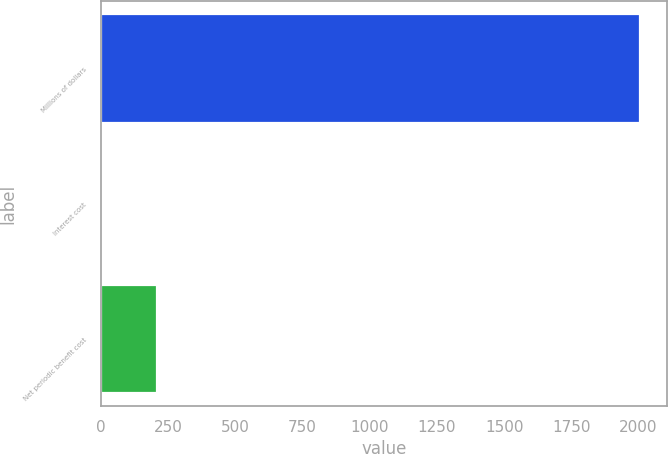Convert chart. <chart><loc_0><loc_0><loc_500><loc_500><bar_chart><fcel>Millions of dollars<fcel>Interest cost<fcel>Net periodic benefit cost<nl><fcel>2007<fcel>8<fcel>207.9<nl></chart> 